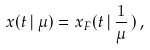Convert formula to latex. <formula><loc_0><loc_0><loc_500><loc_500>x ( t \, | \, \mu ) = x _ { F } ( t \, | \, \frac { 1 } { \mu } \, ) \, ,</formula> 